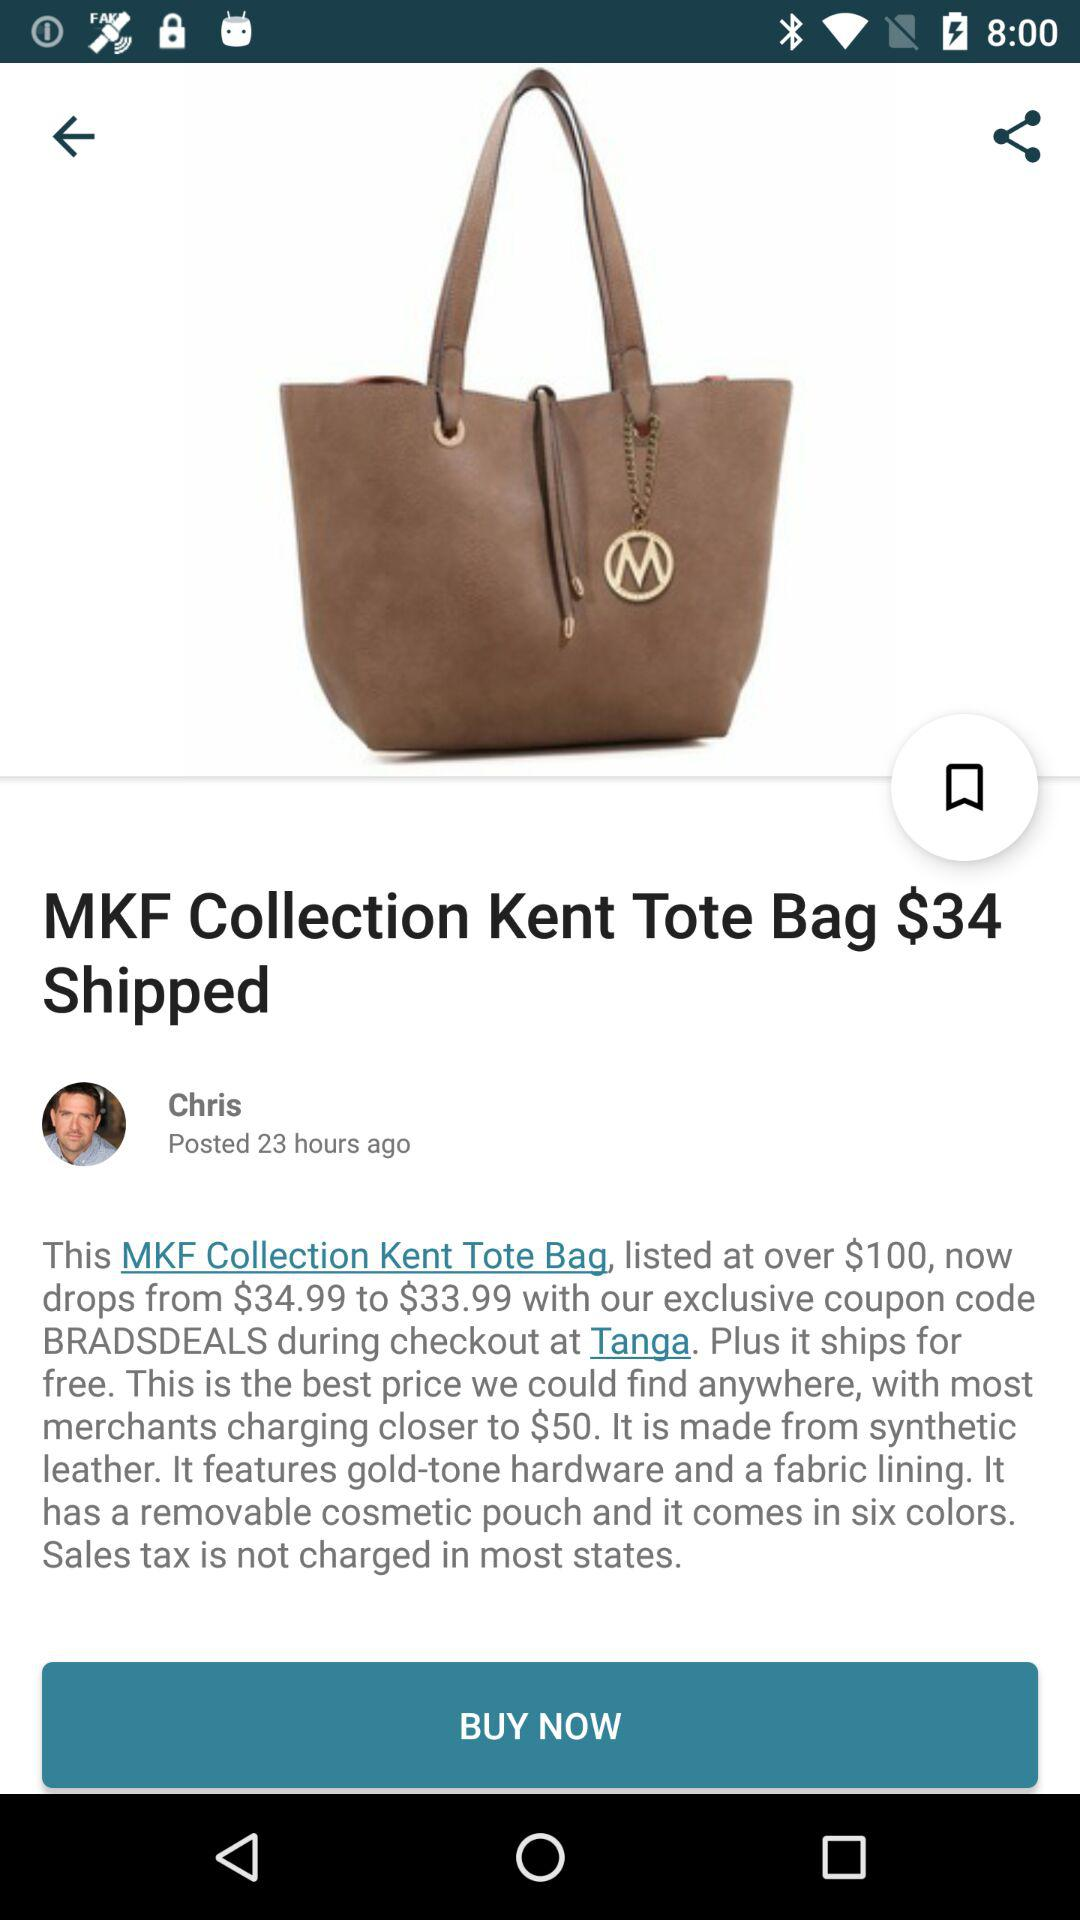How much is the MKF Collection Kent Tote Bag with the coupon code applied?
Answer the question using a single word or phrase. $33.99 